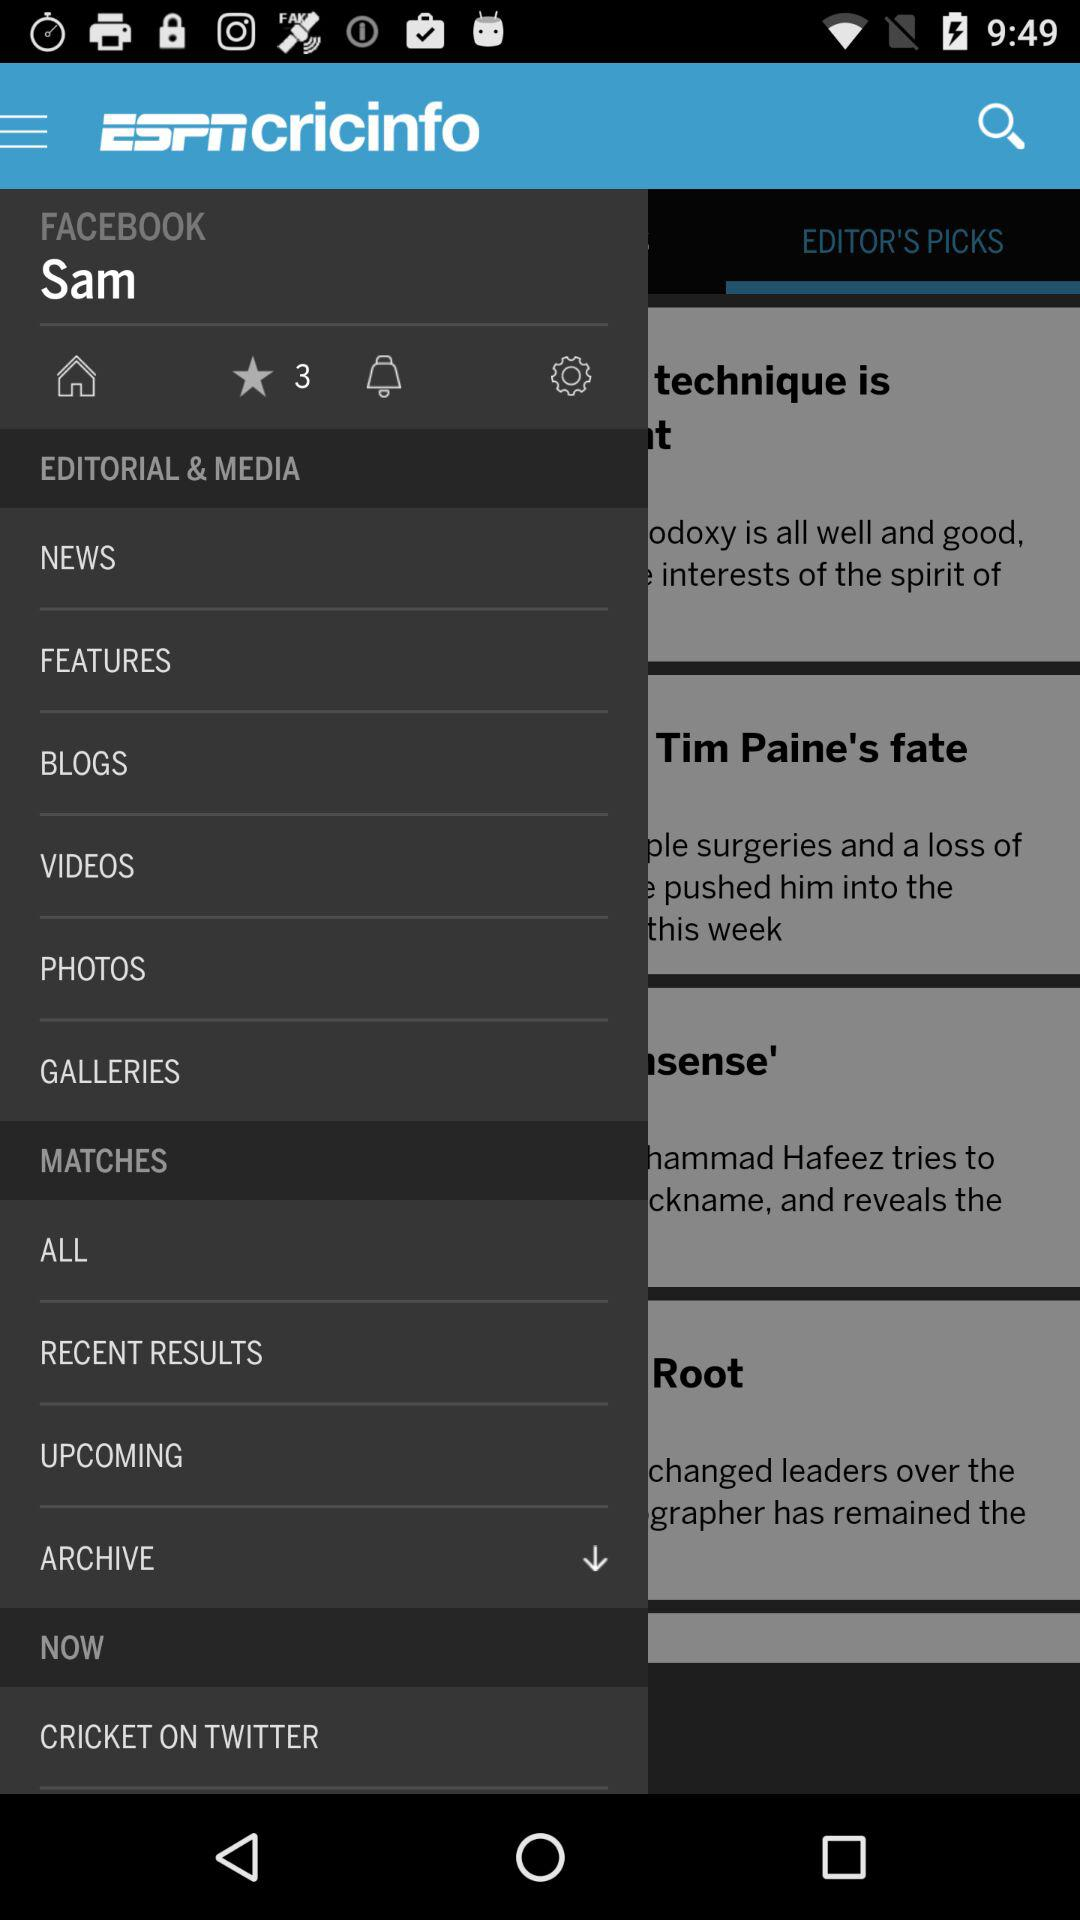What is the name of the user? The name of the user is Sam. 